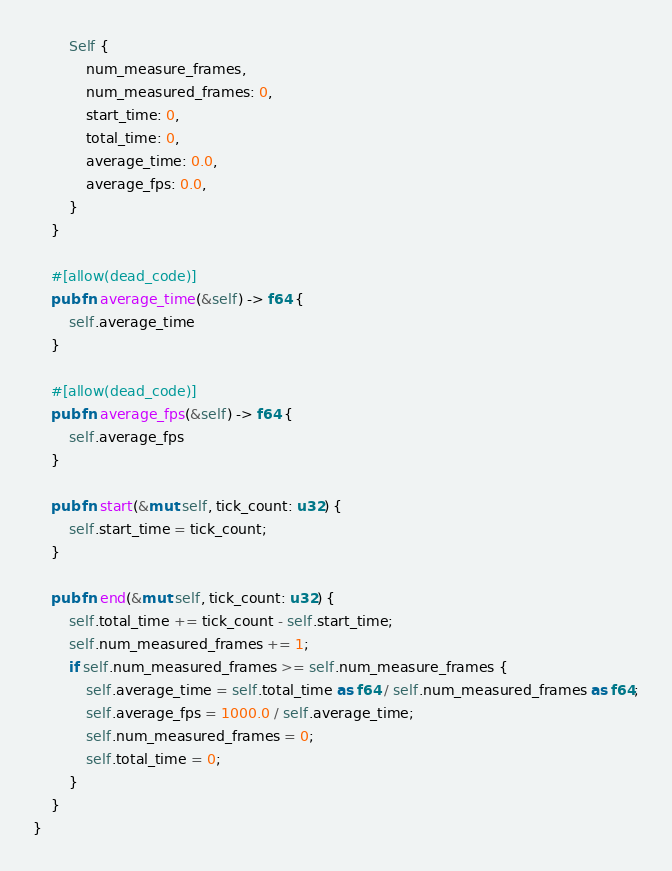<code> <loc_0><loc_0><loc_500><loc_500><_Rust_>        Self {
            num_measure_frames,
            num_measured_frames: 0,
            start_time: 0,
            total_time: 0,
            average_time: 0.0,
            average_fps: 0.0,
        }
    }

    #[allow(dead_code)]
    pub fn average_time(&self) -> f64 {
        self.average_time
    }

    #[allow(dead_code)]
    pub fn average_fps(&self) -> f64 {
        self.average_fps
    }

    pub fn start(&mut self, tick_count: u32) {
        self.start_time = tick_count;
    }

    pub fn end(&mut self, tick_count: u32) {
        self.total_time += tick_count - self.start_time;
        self.num_measured_frames += 1;
        if self.num_measured_frames >= self.num_measure_frames {
            self.average_time = self.total_time as f64 / self.num_measured_frames as f64;
            self.average_fps = 1000.0 / self.average_time;
            self.num_measured_frames = 0;
            self.total_time = 0;
        }
    }
}
</code> 